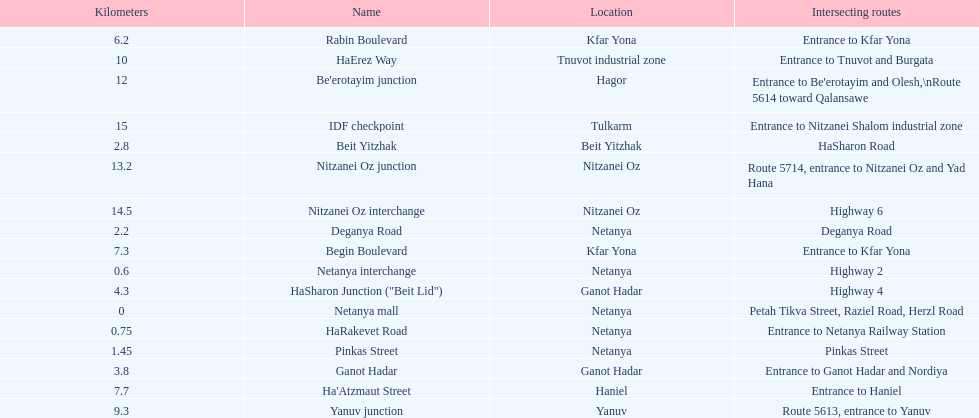Which location comes after kfar yona? Haniel. 